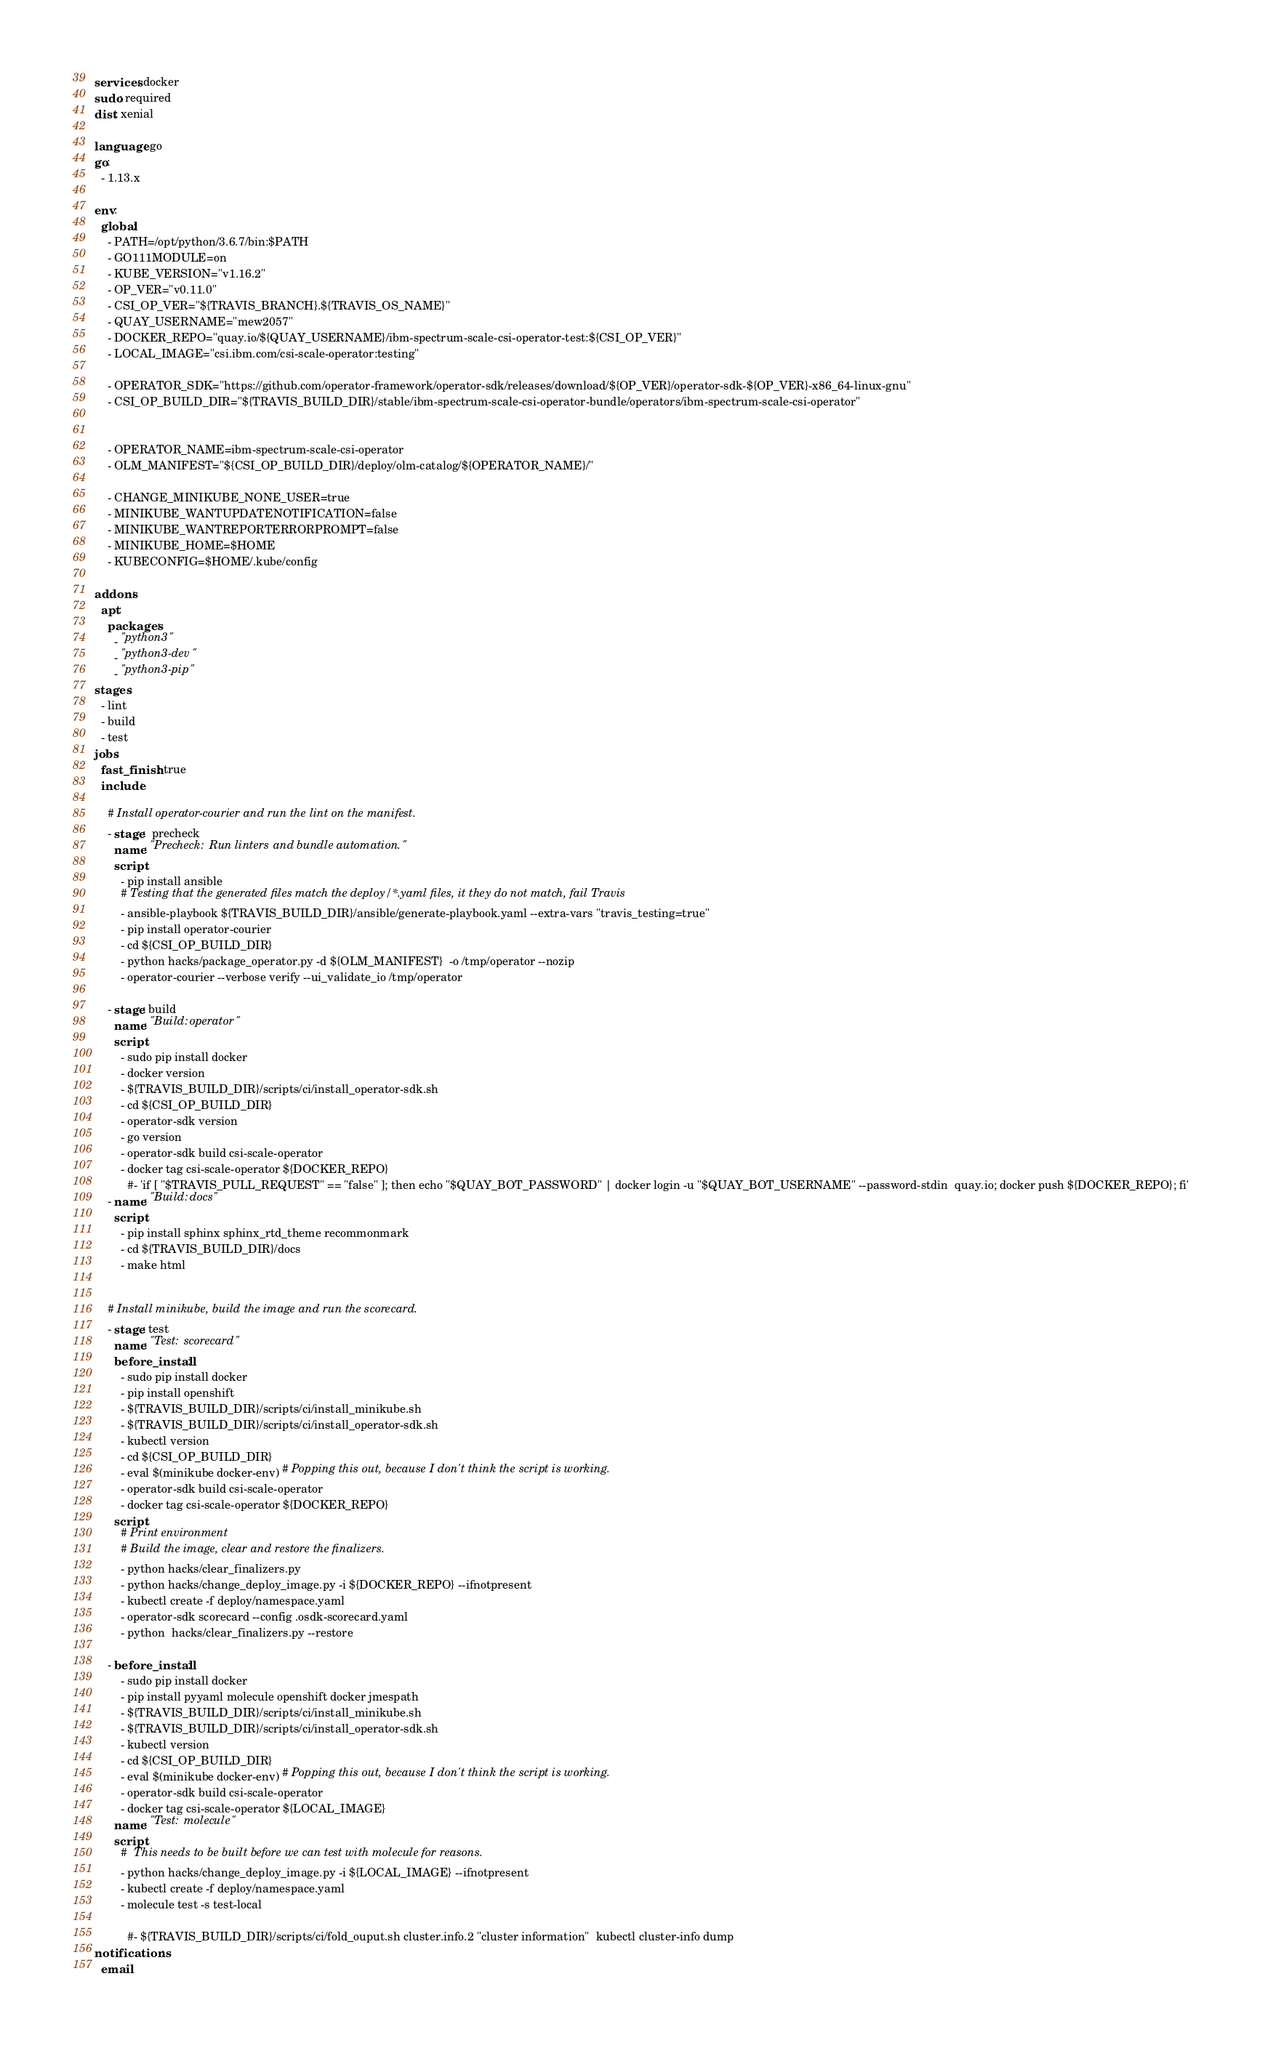<code> <loc_0><loc_0><loc_500><loc_500><_YAML_>services: docker
sudo: required
dist: xenial

language: go
go:
  - 1.13.x

env:
  global:
    - PATH=/opt/python/3.6.7/bin:$PATH
    - GO111MODULE=on
    - KUBE_VERSION="v1.16.2"
    - OP_VER="v0.11.0"
    - CSI_OP_VER="${TRAVIS_BRANCH}.${TRAVIS_OS_NAME}"
    - QUAY_USERNAME="mew2057"
    - DOCKER_REPO="quay.io/${QUAY_USERNAME}/ibm-spectrum-scale-csi-operator-test:${CSI_OP_VER}"
    - LOCAL_IMAGE="csi.ibm.com/csi-scale-operator:testing"

    - OPERATOR_SDK="https://github.com/operator-framework/operator-sdk/releases/download/${OP_VER}/operator-sdk-${OP_VER}-x86_64-linux-gnu"
    - CSI_OP_BUILD_DIR="${TRAVIS_BUILD_DIR}/stable/ibm-spectrum-scale-csi-operator-bundle/operators/ibm-spectrum-scale-csi-operator"


    - OPERATOR_NAME=ibm-spectrum-scale-csi-operator
    - OLM_MANIFEST="${CSI_OP_BUILD_DIR}/deploy/olm-catalog/${OPERATOR_NAME}/"

    - CHANGE_MINIKUBE_NONE_USER=true
    - MINIKUBE_WANTUPDATENOTIFICATION=false
    - MINIKUBE_WANTREPORTERRORPROMPT=false
    - MINIKUBE_HOME=$HOME
    - KUBECONFIG=$HOME/.kube/config

addons:
  apt:
    packages:
      - "python3"
      - "python3-dev"
      - "python3-pip" 
stages:
  - lint
  - build
  - test
jobs:
  fast_finish: true
  include:
    
    # Install operator-courier and run the lint on the manifest.
    - stage:  precheck 
      name: "Precheck: Run linters and bundle automation."
      script:
        - pip install ansible
        # Testing that the generated files match the deploy/*.yaml files, it they do not match, fail Travis
        - ansible-playbook ${TRAVIS_BUILD_DIR}/ansible/generate-playbook.yaml --extra-vars "travis_testing=true"
        - pip install operator-courier
        - cd ${CSI_OP_BUILD_DIR}
        - python hacks/package_operator.py -d ${OLM_MANIFEST}  -o /tmp/operator --nozip 
        - operator-courier --verbose verify --ui_validate_io /tmp/operator

    - stage: build
      name: "Build: operator"
      script:
        - sudo pip install docker
        - docker version
        - ${TRAVIS_BUILD_DIR}/scripts/ci/install_operator-sdk.sh
        - cd ${CSI_OP_BUILD_DIR}
        - operator-sdk version
        - go version
        - operator-sdk build csi-scale-operator
        - docker tag csi-scale-operator ${DOCKER_REPO}
          #- 'if [ "$TRAVIS_PULL_REQUEST" == "false" ]; then echo "$QUAY_BOT_PASSWORD" | docker login -u "$QUAY_BOT_USERNAME" --password-stdin  quay.io; docker push ${DOCKER_REPO}; fi'
    - name: "Build: docs"
      script:
        - pip install sphinx sphinx_rtd_theme recommonmark 
        - cd ${TRAVIS_BUILD_DIR}/docs
        - make html


    # Install minikube, build the image and run the scorecard.
    - stage: test
      name: "Test: scorecard"
      before_install:
        - sudo pip install docker
        - pip install openshift
        - ${TRAVIS_BUILD_DIR}/scripts/ci/install_minikube.sh
        - ${TRAVIS_BUILD_DIR}/scripts/ci/install_operator-sdk.sh
        - kubectl version
        - cd ${CSI_OP_BUILD_DIR}
        - eval $(minikube docker-env) # Popping this out, because I don't think the script is working.
        - operator-sdk build csi-scale-operator
        - docker tag csi-scale-operator ${DOCKER_REPO}
      script: 
        # Print environment 
        # Build the image, clear and restore the finalizers.
        - python hacks/clear_finalizers.py
        - python hacks/change_deploy_image.py -i ${DOCKER_REPO} --ifnotpresent
        - kubectl create -f deploy/namespace.yaml
        - operator-sdk scorecard --config .osdk-scorecard.yaml
        - python  hacks/clear_finalizers.py --restore
        
    - before_install:
        - sudo pip install docker
        - pip install pyyaml molecule openshift docker jmespath
        - ${TRAVIS_BUILD_DIR}/scripts/ci/install_minikube.sh
        - ${TRAVIS_BUILD_DIR}/scripts/ci/install_operator-sdk.sh
        - kubectl version
        - cd ${CSI_OP_BUILD_DIR}
        - eval $(minikube docker-env) # Popping this out, because I don't think the script is working.
        - operator-sdk build csi-scale-operator
        - docker tag csi-scale-operator ${LOCAL_IMAGE}
      name: "Test: molecule"
      script: 
        #  This needs to be built before we can test with molecule for reasons.
        - python hacks/change_deploy_image.py -i ${LOCAL_IMAGE} --ifnotpresent
        - kubectl create -f deploy/namespace.yaml
        - molecule test -s test-local

          #- ${TRAVIS_BUILD_DIR}/scripts/ci/fold_ouput.sh cluster.info.2 "cluster information"  kubectl cluster-info dump
notifications:
  email:</code> 